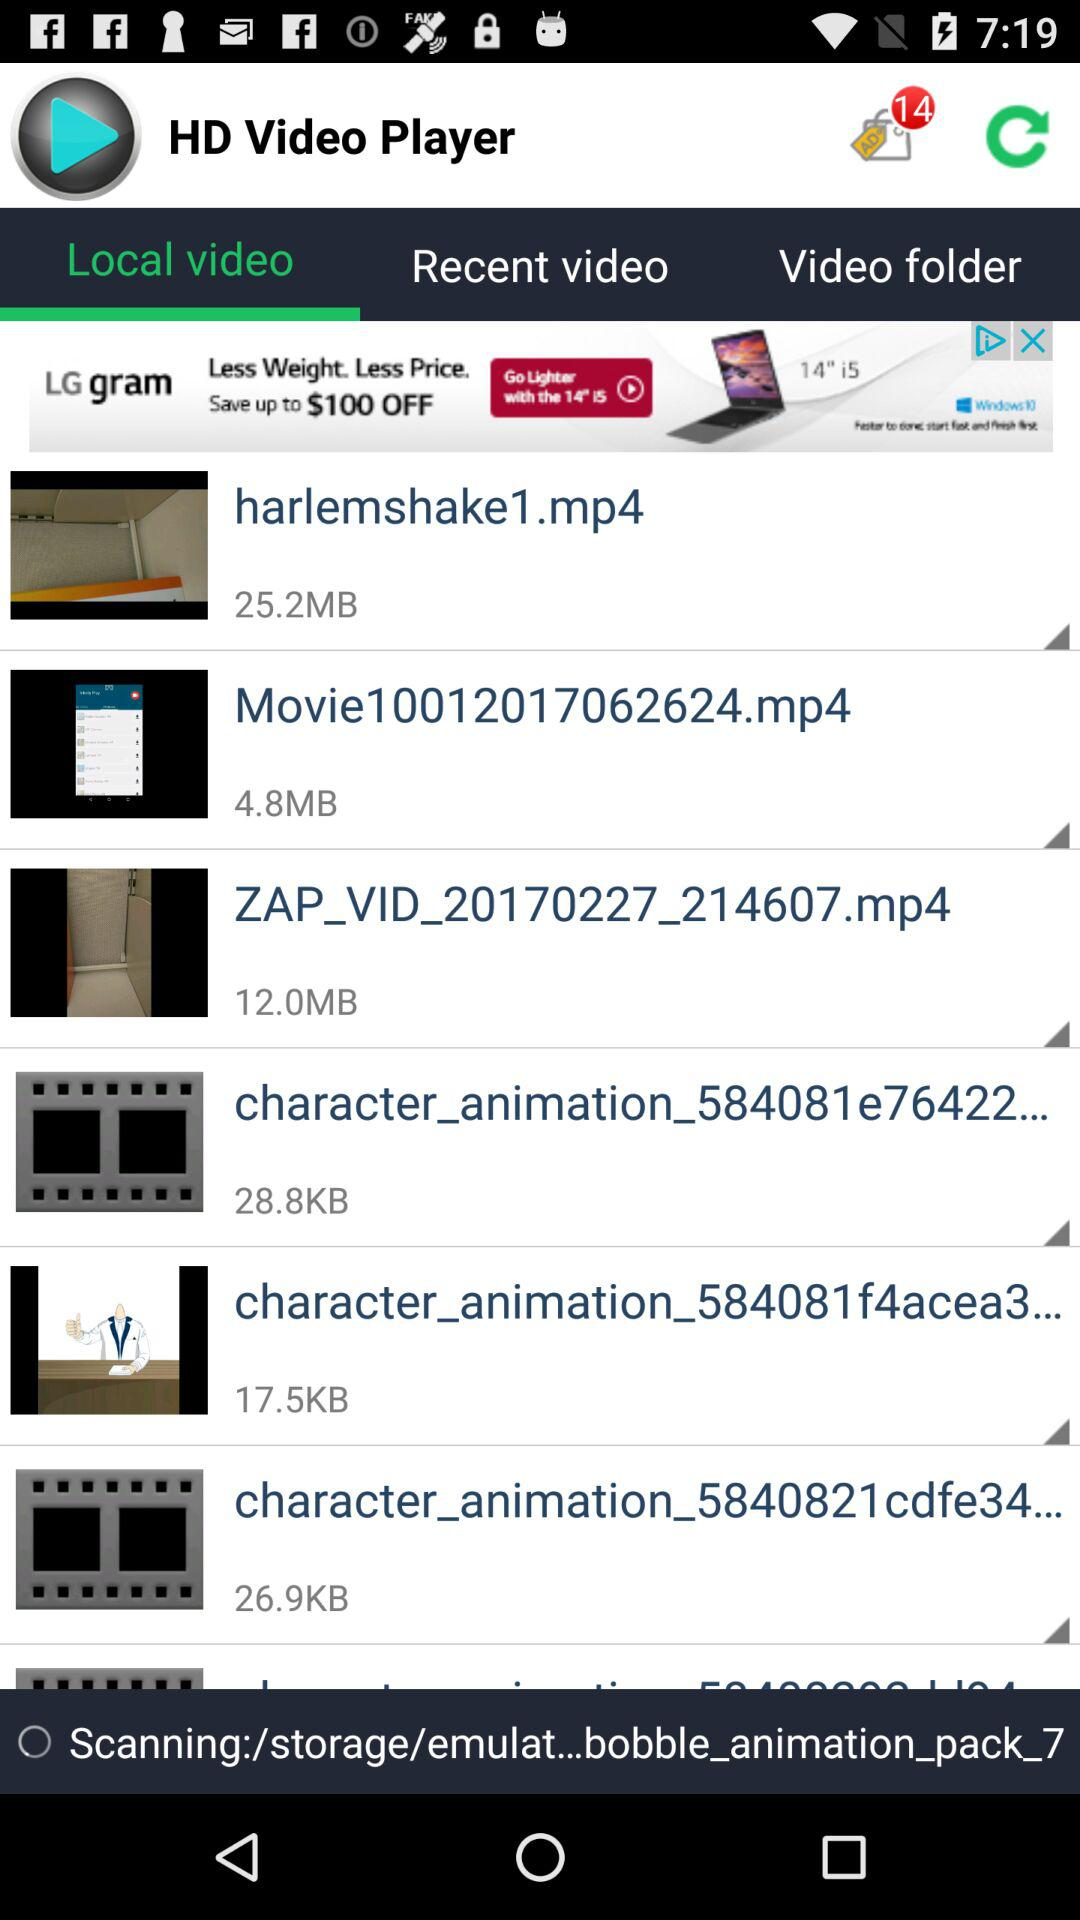How many files are larger than 10MB?
Answer the question using a single word or phrase. 2 